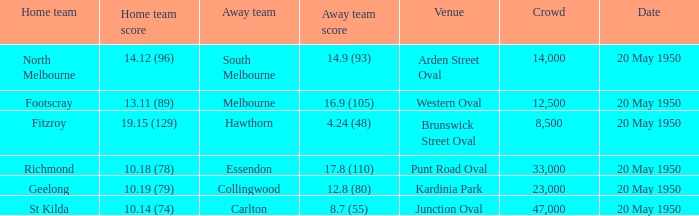What was the date of the game when the away team was south melbourne? 20 May 1950. 